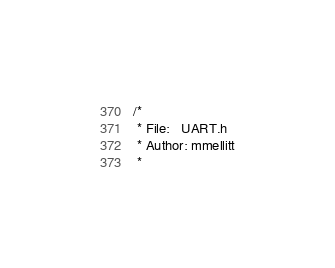Convert code to text. <code><loc_0><loc_0><loc_500><loc_500><_C_>/* 
 * File:   UART.h
 * Author: mmellitt
 *</code> 